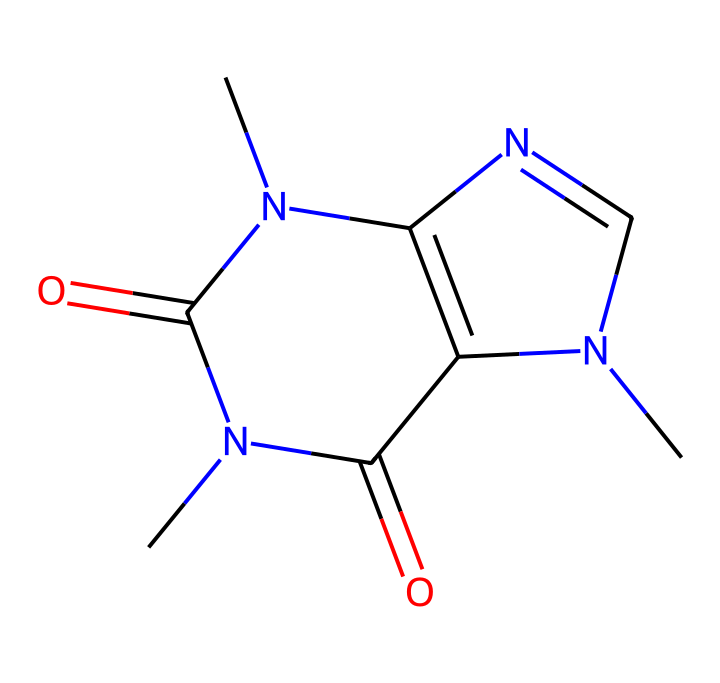What is the molecular formula of caffeine? To determine the molecular formula, we need to count the different types of atoms present in the structure. In this case, caffeine has 8 carbon (C), 10 hydrogen (H), 4 nitrogen (N), and 2 oxygen (O) atoms. Combining these counts gives the molecular formula C8H10N4O2.
Answer: C8H10N4O2 How many nitrogen atoms are in caffeine? By analyzing the structure, we can see 4 nitrogen (N) atoms indicated by the N symbols present in the chemical structure.
Answer: 4 What type of chemical structure is caffeine classified as? Caffeine is classified as a xanthine alkaloid due to its structure and nitrogen content. This classification is informed by the presence of multiple nitrogen atoms and a characteristic ring structure.
Answer: xanthine alkaloid What type of bond connects carbon atoms in caffeine? The carbon atoms in caffeine are primarily connected by single covalent bonds, evidenced by their arrangement and the connections shown in the structural representation.
Answer: single covalent How many rings are present in the caffeine structure? Upon examining the structure of caffeine, we can identify two fused rings, which contribute to its classification as a bicyclic compound.
Answer: 2 Which part of the structure contributes to caffeine’s stimulant properties? The nitrogen atoms, especially within the ring structure, are responsible for the stimulant properties of caffeine, as nitrogen atoms impact the interaction with adenosine receptors in the brain.
Answer: nitrogen atoms Is caffeine a polar or non-polar molecule? The presence of multiple functional groups, including nitrogen and oxygen, contributes to the polarity of caffeine, making it polar overall.
Answer: polar 